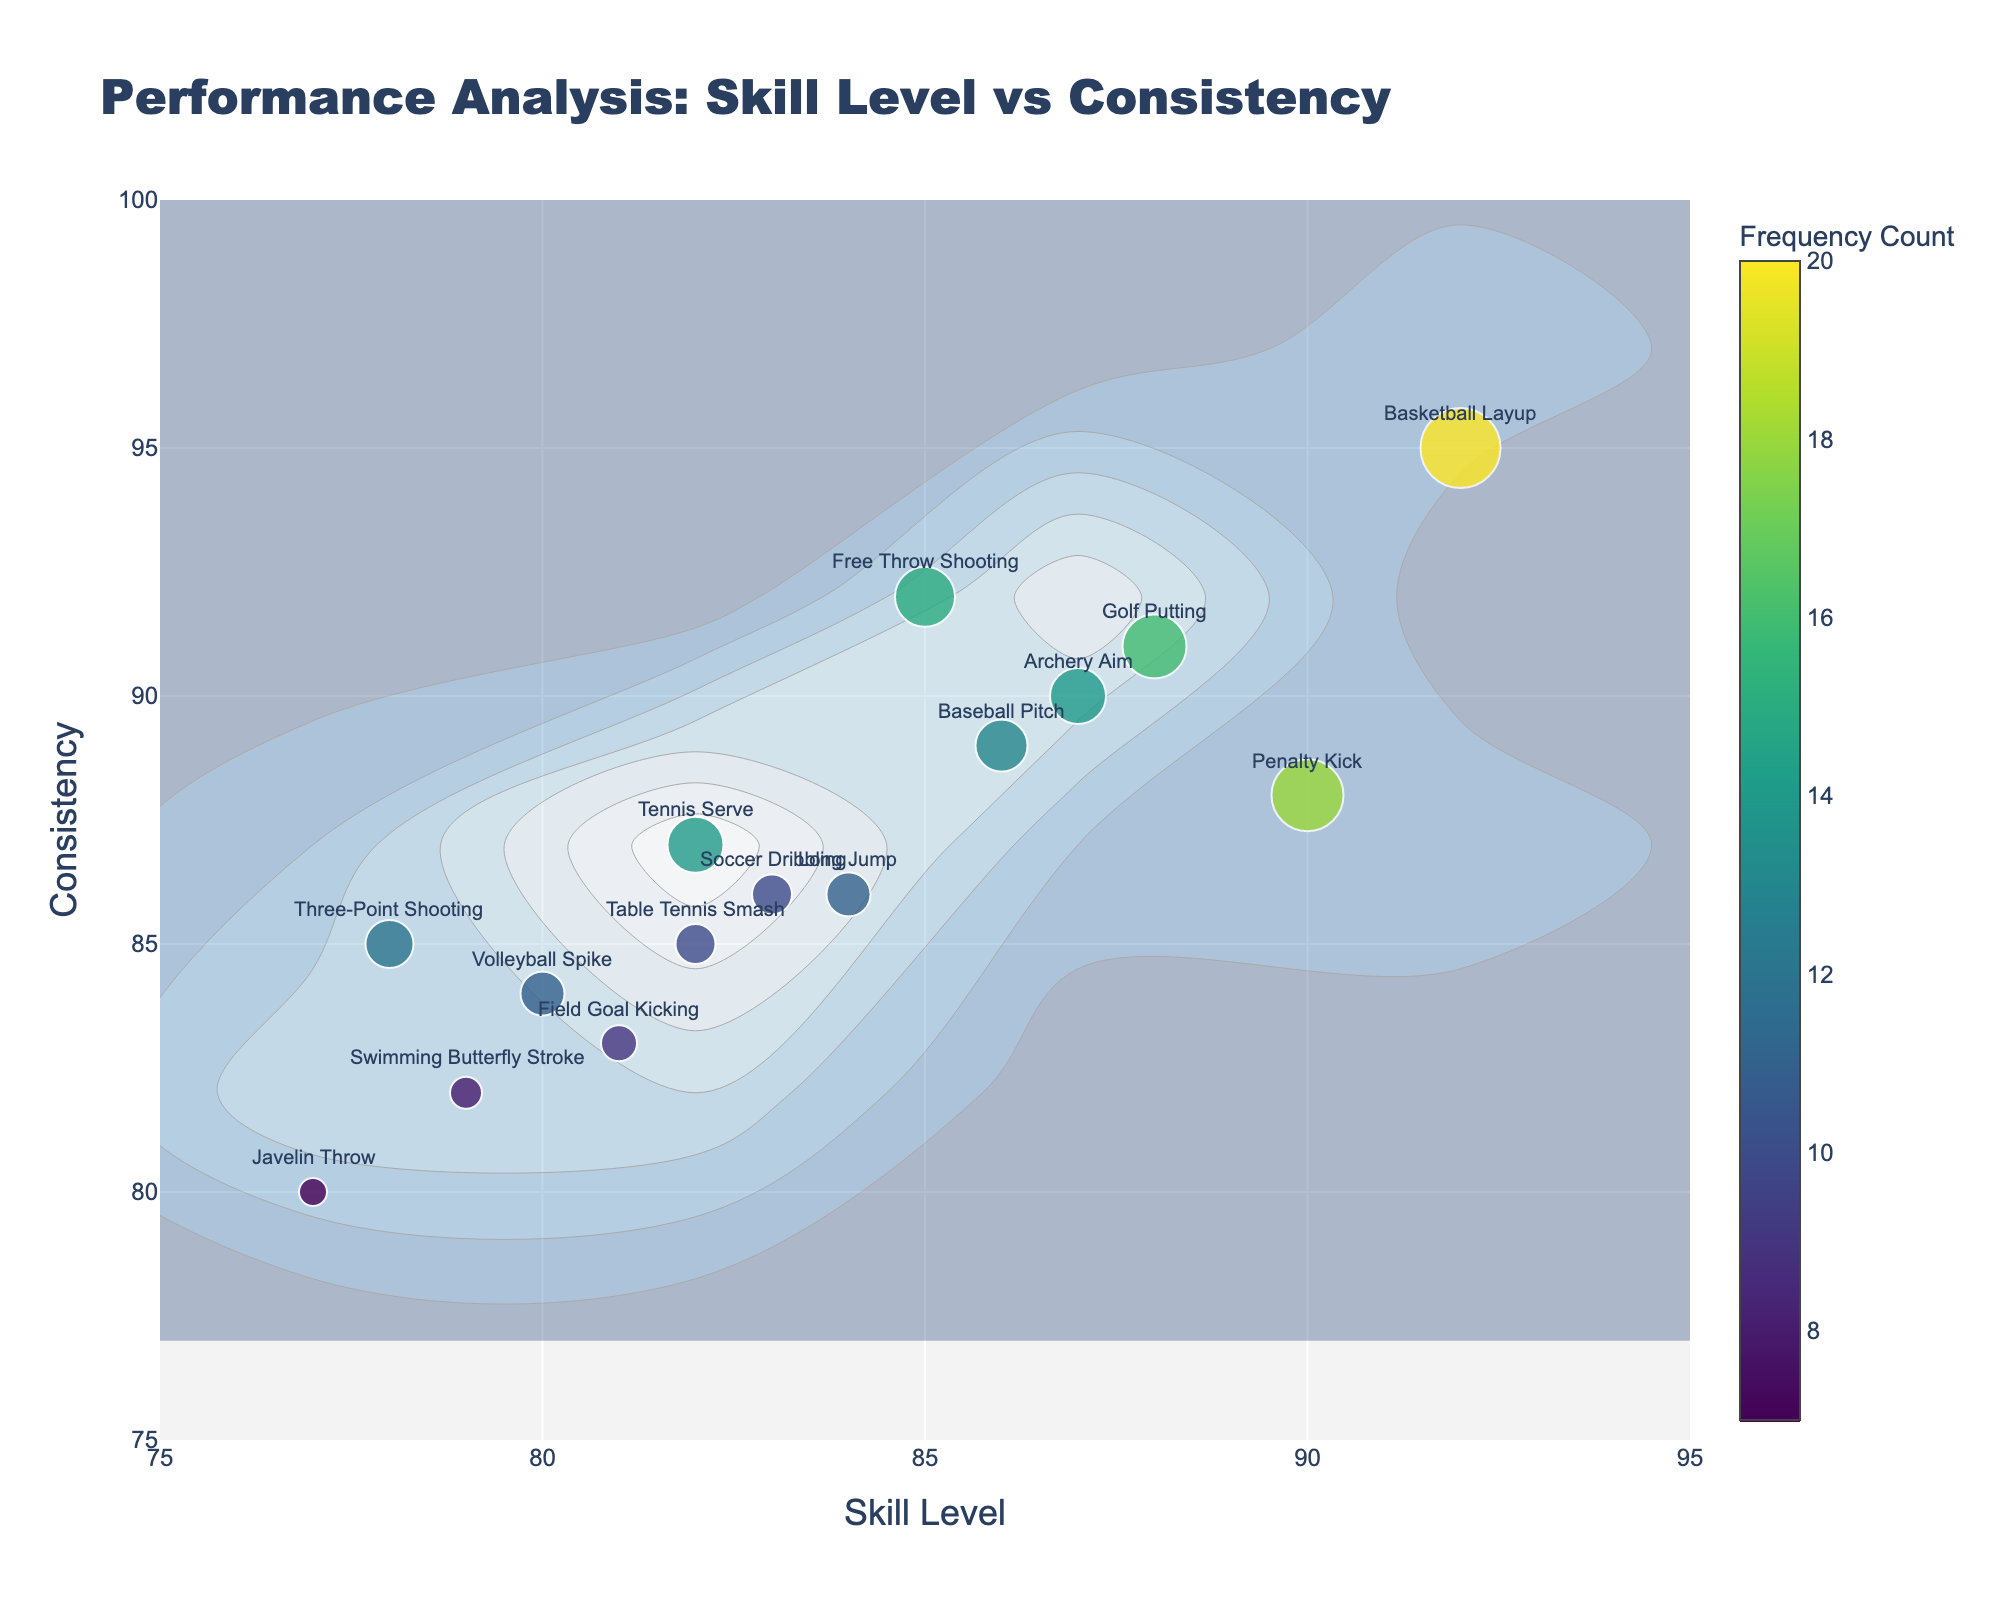What's the title of the figure? The title is usually located at the top of the figure and gives a brief overview of what the figure represents. In this case, it shows the title: "Performance Analysis: Skill Level vs Consistency".
Answer: Performance Analysis: Skill Level vs Consistency How many data points represent different techniques in the figure? Each unique technique is represented by a point on the scatter plot. By counting the points or reviewing the data, we can see there are 15 techniques.
Answer: 15 What is the range of the 'Skill Level' axis? The range of the 'Skill Level' axis can be determined by looking at the minimum and maximum values displayed. Here, the range is from 75 to 95.
Answer: 75 to 95 Which technique has the highest consistency? The technique with the highest value on the y-axis (Consistency) can be identified from the figure. "Basketball Layup" has a consistency value of 95.
Answer: Basketball Layup What is the average skill level of 'Free Throw Shooting' and 'Three-Point Shooting'? To find the average, add the skill levels of two techniques and divide by 2. That is (85 + 78) / 2 = 81.5.
Answer: 81.5 Which techniques have a skill level greater than 85? By examining the x-axis (Skill Level), techniques with values above 85 include "Free Throw Shooting", "Penalty Kick", "Golf Putting", "Basketball Layup", "Baseball Pitch", "Archery Aim".
Answer: Free Throw Shooting, Penalty Kick, Golf Putting, Basketball Layup, Baseball Pitch, Archery Aim Which technique is represented with the largest marker size and why? Marker sizes indicate frequency count, with larger sizes representing higher counts. "Basketball Layup" has the largest marker size with a frequency count of 20.
Answer: Basketball Layup What is the relationship between 'Skill Level' and 'Consistency' for 'Volleyball Spike'? Locate the 'Volleyball Spike' on the plot to observe its coordinates. 'Volleyball Spike' has a skill level of 80 and consistency of 84.
Answer: Skill Level: 80, Consistency: 84 Which technique has the lowest frequency count and what is this count? The technique with the smallest marker size has the lowest frequency count. According to the data, "Javelin Throw" has the lowest frequency count of 7.
Answer: Javelin Throw, 7 